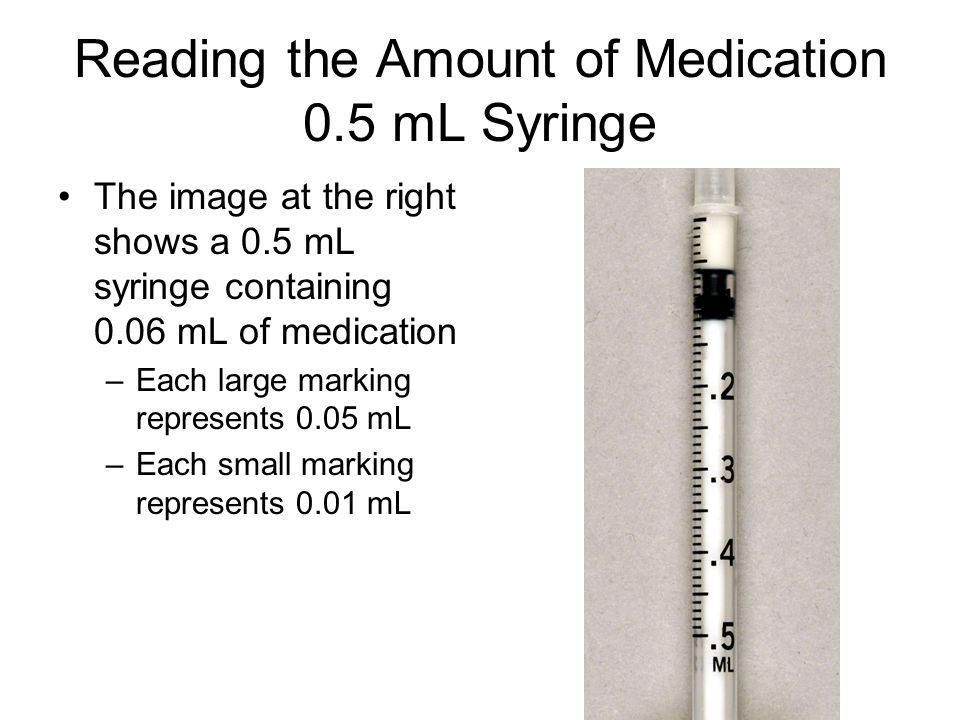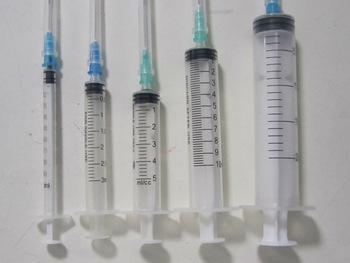The first image is the image on the left, the second image is the image on the right. Evaluate the accuracy of this statement regarding the images: "There is a single syringe in one of the images and at least twice as many in the other.". Is it true? Answer yes or no. Yes. The first image is the image on the left, the second image is the image on the right. Assess this claim about the two images: "There are more needles in the right image.". Correct or not? Answer yes or no. Yes. 